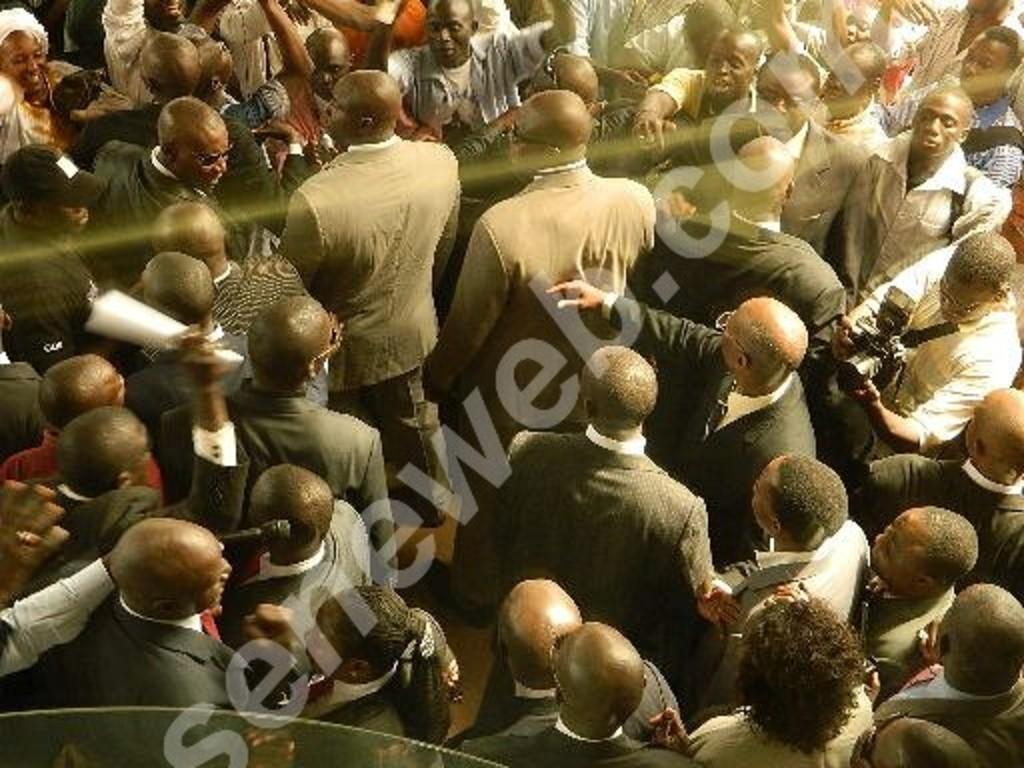How many people are in the image? There is a group of people in the image. What is one person in the group doing? A man is holding a camera in the image. Can you describe any text visible in the image? There is text visible on the image. How many grapes are being held by the people in the image? There are no grapes visible in the image. What type of feeling is being expressed by the people in the image? The image does not convey any specific feelings or emotions; it only shows a group of people and a man holding a camera. 